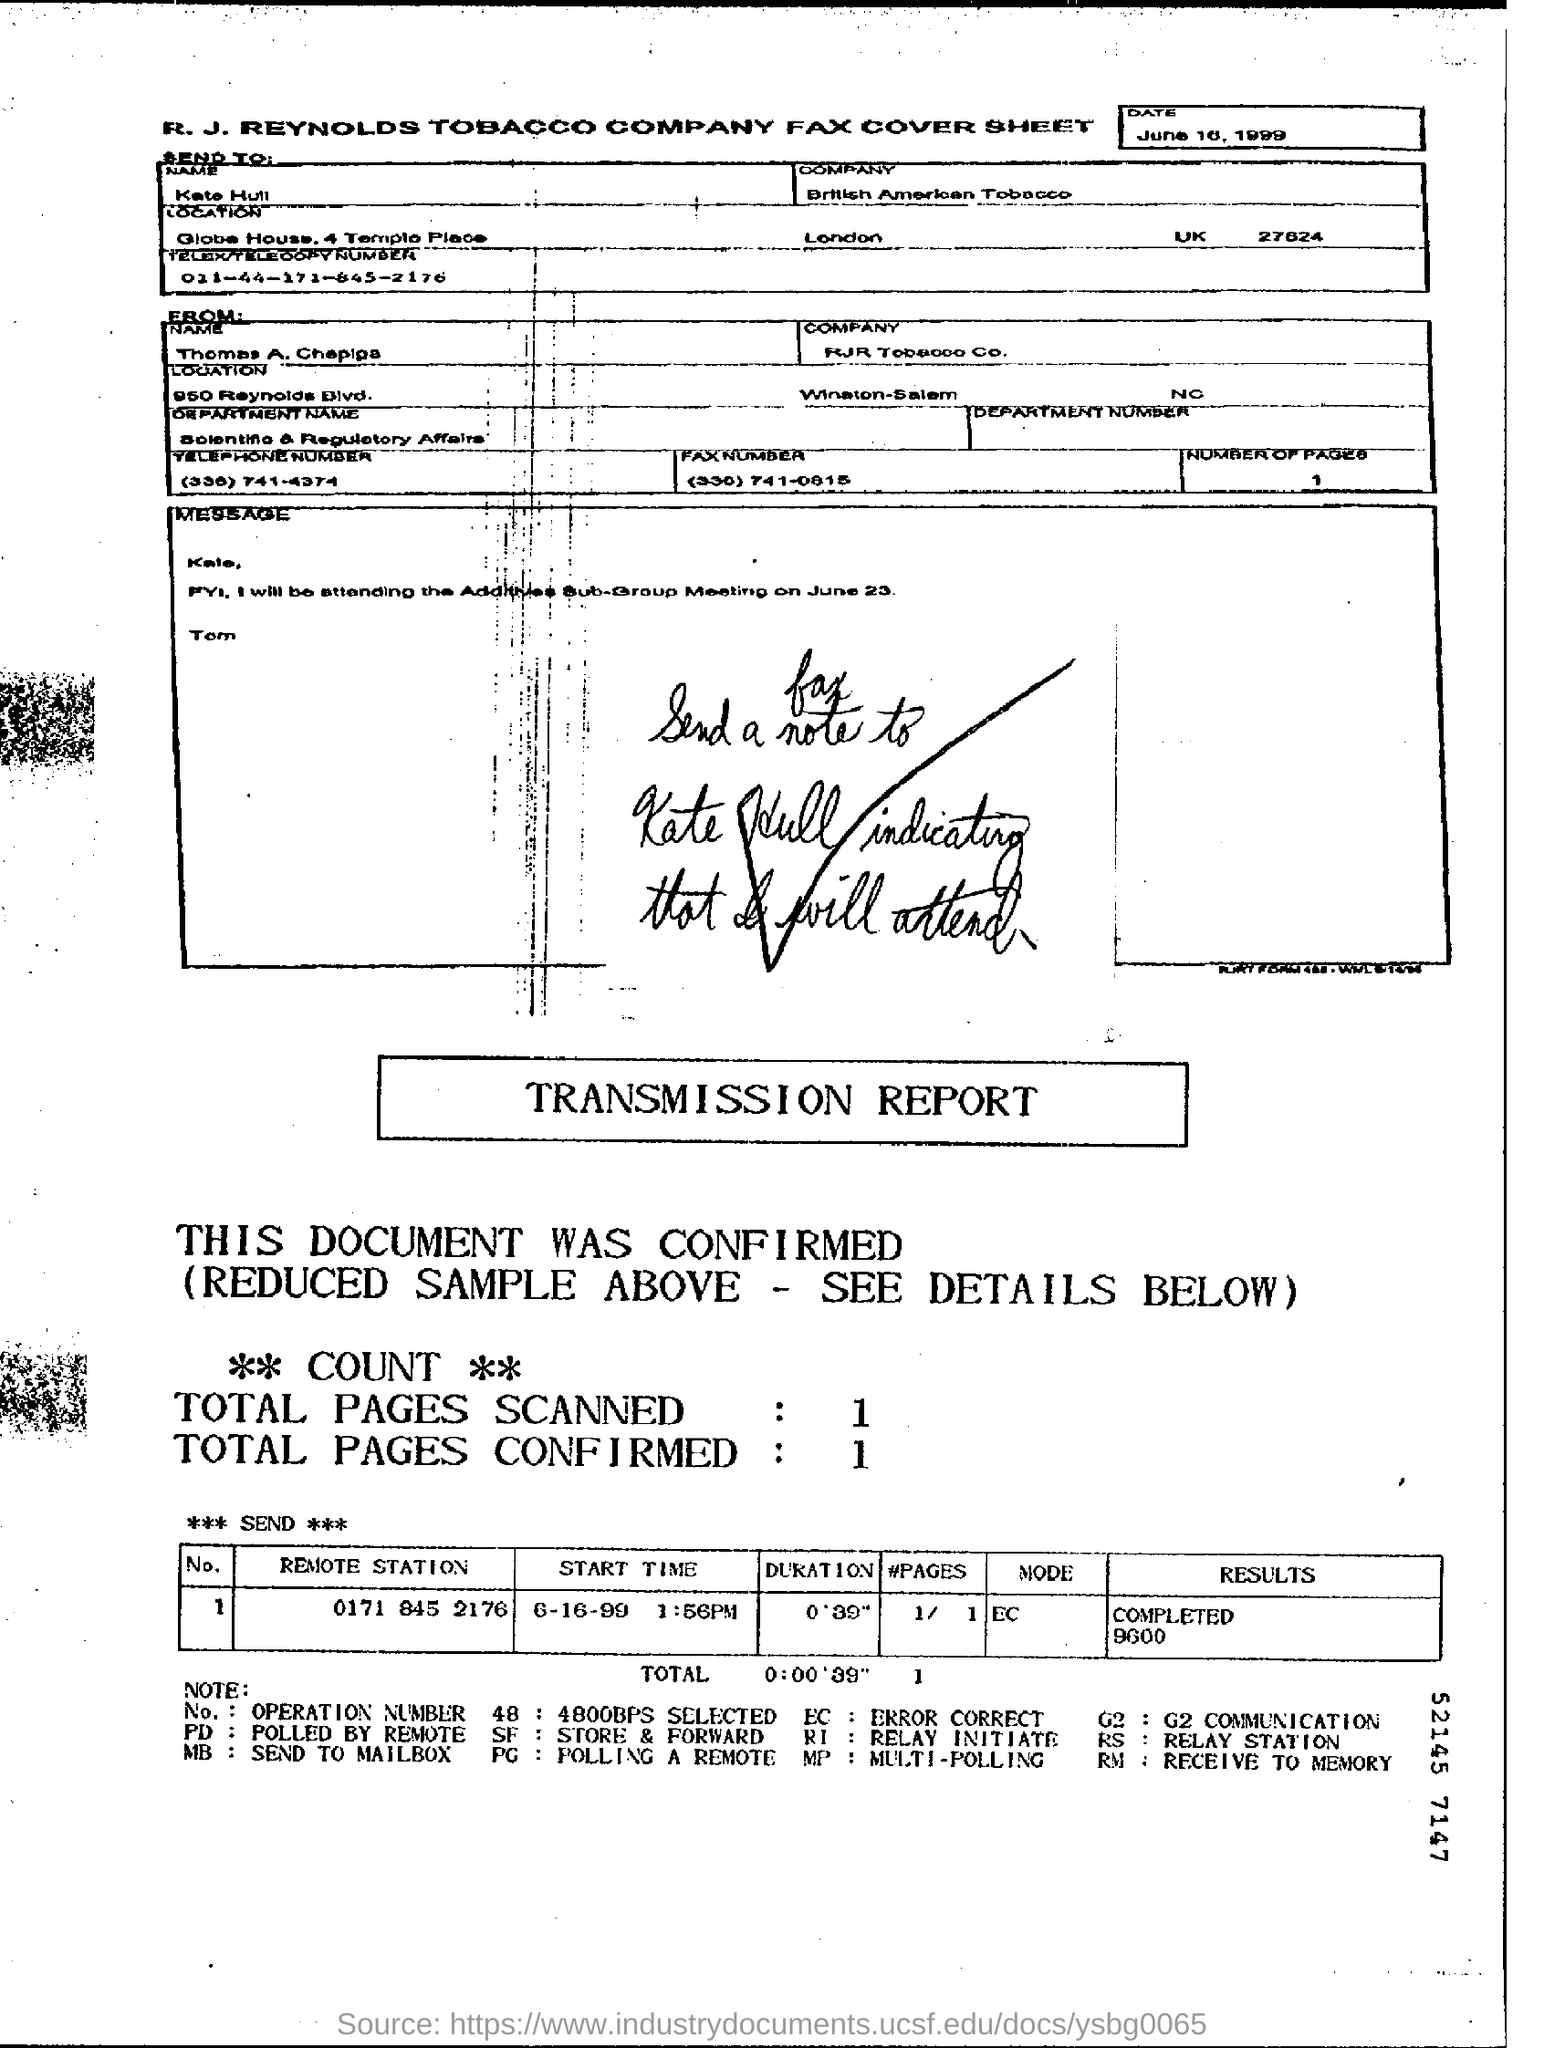Draw attention to some important aspects in this diagram. The remote station belonging to Operation Number (No.) 1 is 0171 845 2176. The total duration mentioned in the transmission report is 0' 39'', as stated in the transmission report. The Start time mentioned in the transmission report is June 16, 1999 at 1:56 PM. Kate Hull works for British American Tobacco. The fax cover sheet is that of the R. J. Reynolds Tobacco Company. 